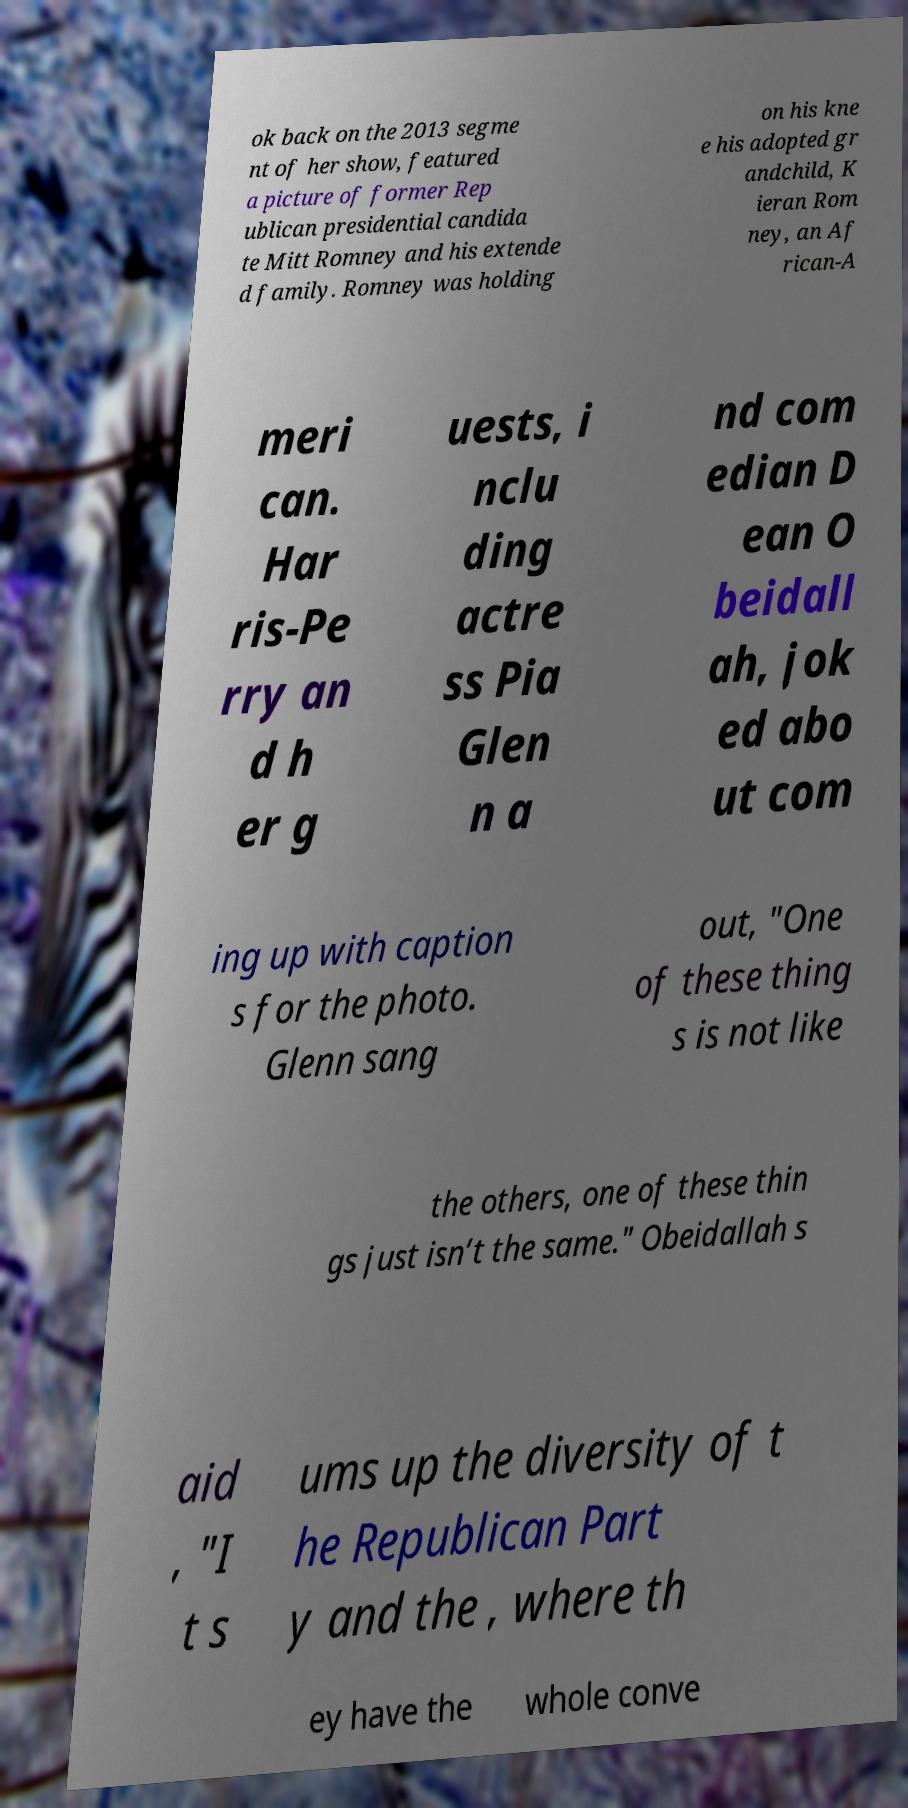For documentation purposes, I need the text within this image transcribed. Could you provide that? ok back on the 2013 segme nt of her show, featured a picture of former Rep ublican presidential candida te Mitt Romney and his extende d family. Romney was holding on his kne e his adopted gr andchild, K ieran Rom ney, an Af rican-A meri can. Har ris-Pe rry an d h er g uests, i nclu ding actre ss Pia Glen n a nd com edian D ean O beidall ah, jok ed abo ut com ing up with caption s for the photo. Glenn sang out, "One of these thing s is not like the others, one of these thin gs just isn’t the same." Obeidallah s aid , "I t s ums up the diversity of t he Republican Part y and the , where th ey have the whole conve 